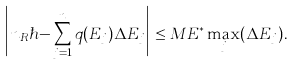Convert formula to latex. <formula><loc_0><loc_0><loc_500><loc_500>\Big { | } n _ { R } \hbar { - } \sum _ { j = 1 } ^ { n } q ( E _ { j } ) \Delta E _ { j } \Big { | } \leq M E ^ { \ast } \max _ { j } ( \Delta E _ { j } ) .</formula> 